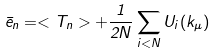Convert formula to latex. <formula><loc_0><loc_0><loc_500><loc_500>\bar { e } _ { n } = < T _ { n } > + \frac { 1 } { 2 N } \sum _ { i < N } U _ { i } ( k _ { \mu } )</formula> 